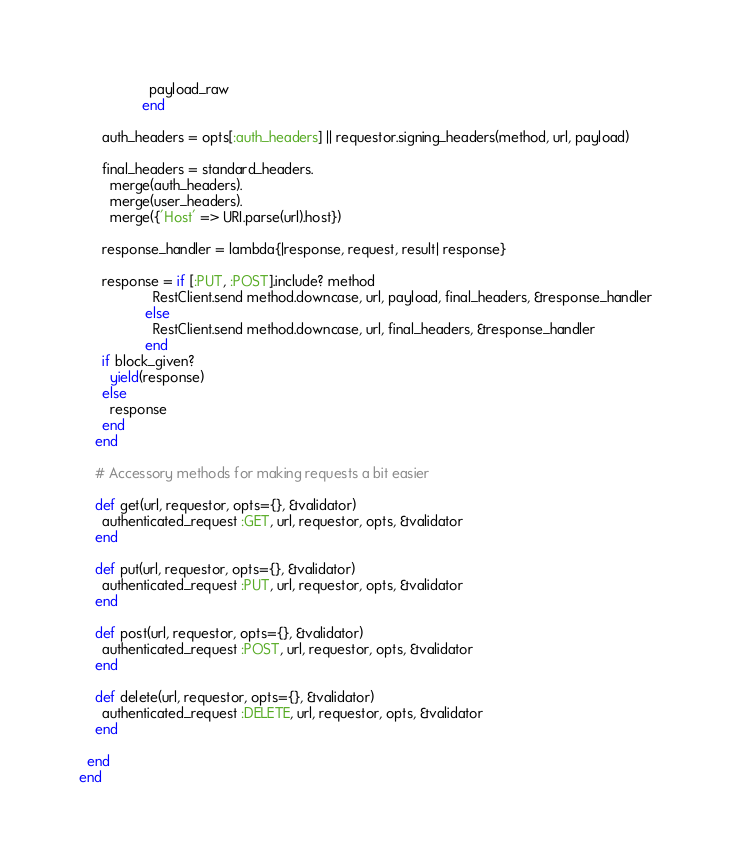<code> <loc_0><loc_0><loc_500><loc_500><_Ruby_>                  payload_raw
                end

      auth_headers = opts[:auth_headers] || requestor.signing_headers(method, url, payload)

      final_headers = standard_headers.
        merge(auth_headers).
        merge(user_headers).
        merge({'Host' => URI.parse(url).host})

      response_handler = lambda{|response, request, result| response}

      response = if [:PUT, :POST].include? method
                   RestClient.send method.downcase, url, payload, final_headers, &response_handler
                 else
                   RestClient.send method.downcase, url, final_headers, &response_handler
                 end
      if block_given?
        yield(response)
      else
        response
      end
    end

    # Accessory methods for making requests a bit easier

    def get(url, requestor, opts={}, &validator)
      authenticated_request :GET, url, requestor, opts, &validator
    end

    def put(url, requestor, opts={}, &validator)
      authenticated_request :PUT, url, requestor, opts, &validator
    end

    def post(url, requestor, opts={}, &validator)
      authenticated_request :POST, url, requestor, opts, &validator
    end

    def delete(url, requestor, opts={}, &validator)
      authenticated_request :DELETE, url, requestor, opts, &validator
    end

  end
end
</code> 